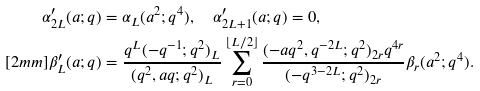Convert formula to latex. <formula><loc_0><loc_0><loc_500><loc_500>\alpha ^ { \prime } _ { 2 L } ( a ; q ) & = \alpha _ { L } ( a ^ { 2 } ; q ^ { 4 } ) , \quad \alpha ^ { \prime } _ { 2 L + 1 } ( a ; q ) = 0 , \\ [ 2 m m ] \beta ^ { \prime } _ { L } ( a ; q ) & = \frac { q ^ { L } ( - q ^ { - 1 } ; q ^ { 2 } ) _ { L } } { ( q ^ { 2 } , a q ; q ^ { 2 } ) _ { L } } \sum _ { r = 0 } ^ { \lfloor L / 2 \rfloor } \frac { ( - a q ^ { 2 } , q ^ { - 2 L } ; q ^ { 2 } ) _ { 2 r } q ^ { 4 r } } { ( - q ^ { 3 - 2 L } ; q ^ { 2 } ) _ { 2 r } } \beta _ { r } ( a ^ { 2 } ; q ^ { 4 } ) .</formula> 